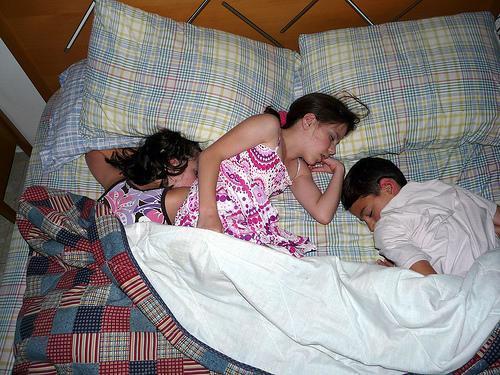How many people are wearing headbands?
Give a very brief answer. 1. 